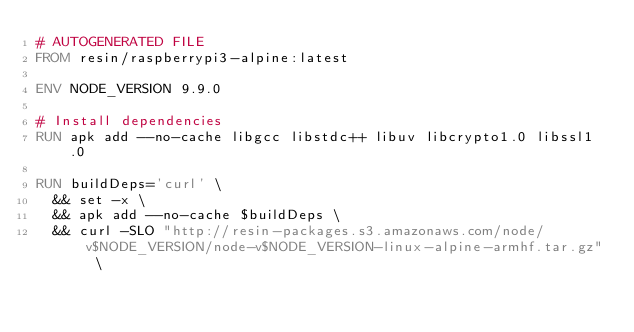Convert code to text. <code><loc_0><loc_0><loc_500><loc_500><_Dockerfile_># AUTOGENERATED FILE
FROM resin/raspberrypi3-alpine:latest

ENV NODE_VERSION 9.9.0

# Install dependencies
RUN apk add --no-cache libgcc libstdc++ libuv libcrypto1.0 libssl1.0

RUN buildDeps='curl' \
	&& set -x \
	&& apk add --no-cache $buildDeps \
	&& curl -SLO "http://resin-packages.s3.amazonaws.com/node/v$NODE_VERSION/node-v$NODE_VERSION-linux-alpine-armhf.tar.gz" \</code> 